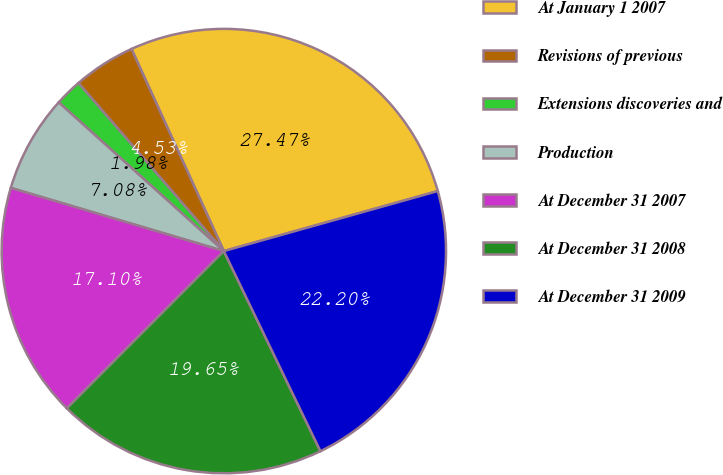Convert chart. <chart><loc_0><loc_0><loc_500><loc_500><pie_chart><fcel>At January 1 2007<fcel>Revisions of previous<fcel>Extensions discoveries and<fcel>Production<fcel>At December 31 2007<fcel>At December 31 2008<fcel>At December 31 2009<nl><fcel>27.47%<fcel>4.53%<fcel>1.98%<fcel>7.08%<fcel>17.1%<fcel>19.65%<fcel>22.2%<nl></chart> 